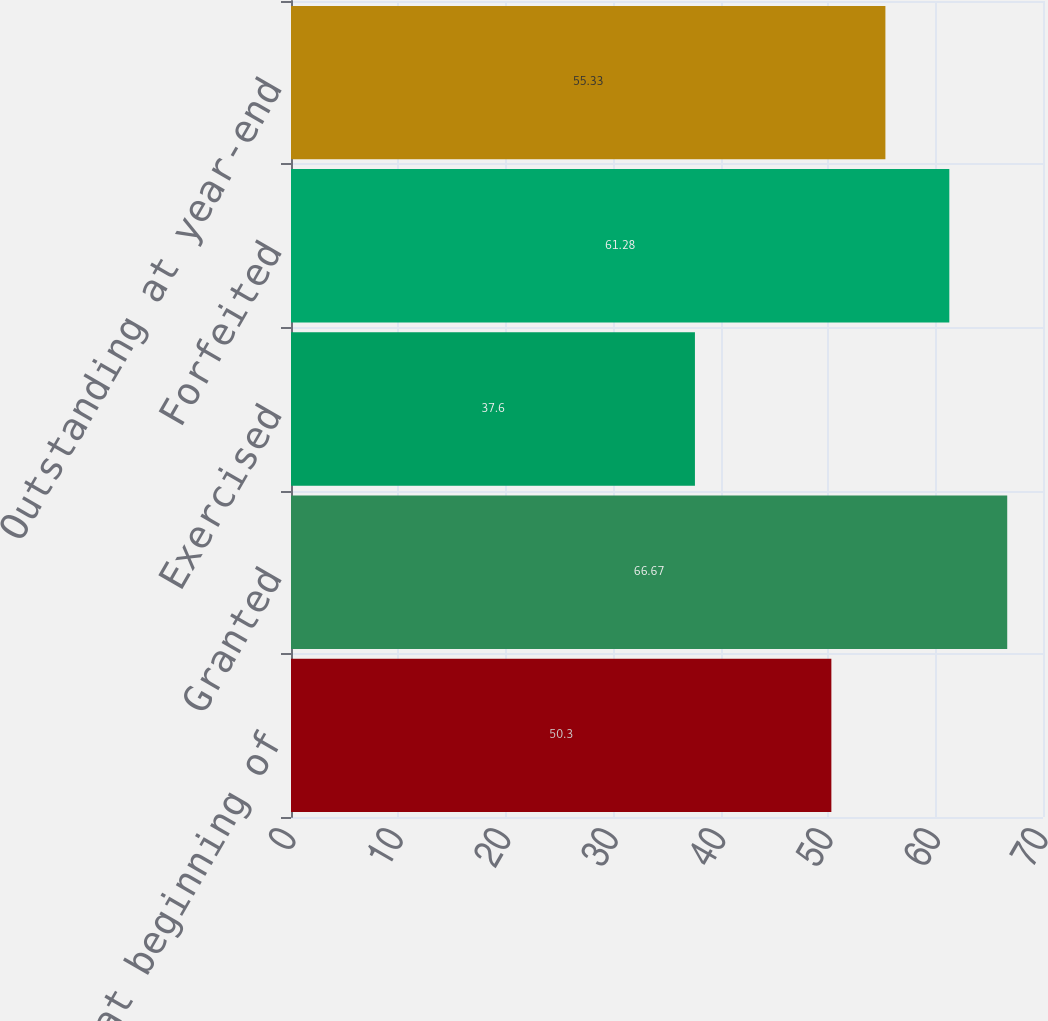Convert chart to OTSL. <chart><loc_0><loc_0><loc_500><loc_500><bar_chart><fcel>Outstanding at beginning of<fcel>Granted<fcel>Exercised<fcel>Forfeited<fcel>Outstanding at year-end<nl><fcel>50.3<fcel>66.67<fcel>37.6<fcel>61.28<fcel>55.33<nl></chart> 